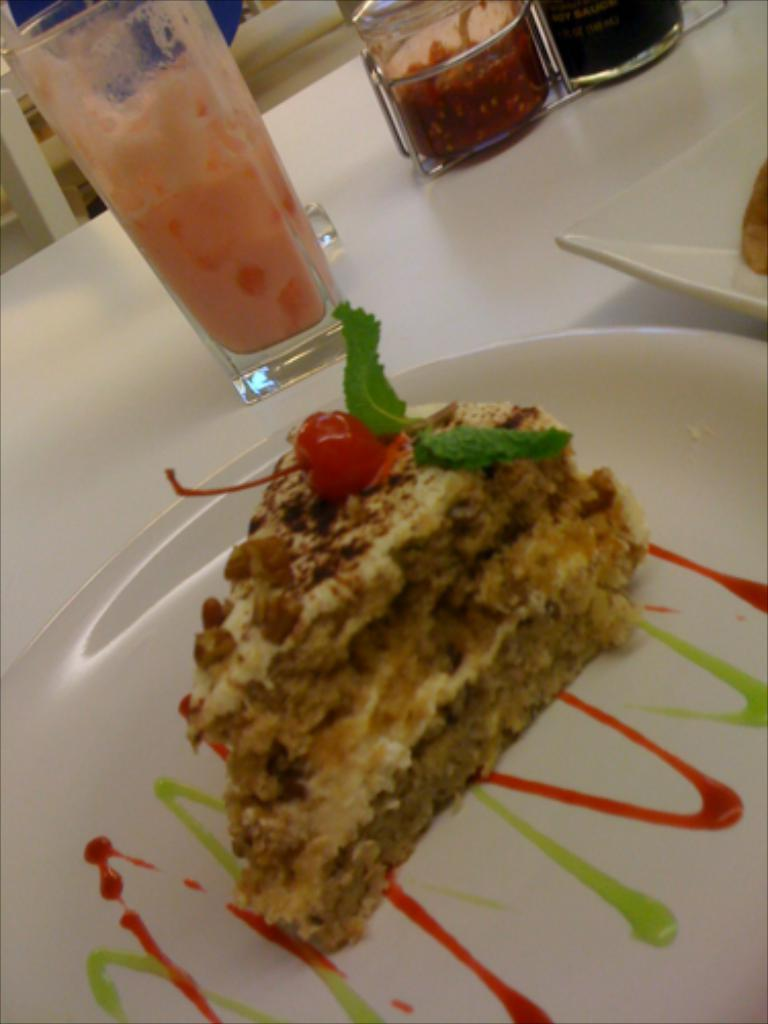What is on the plate that is visible in the image? There is a pastry in a plate in the image. Are there any other plates with food items in the image? Yes, there is another plate with a food item in the image. What can be seen on the table in the image? There are glasses on the table in the image. What type of clouds can be seen in the image? There are no clouds visible in the image; it is an indoor scene with a table and plates. 